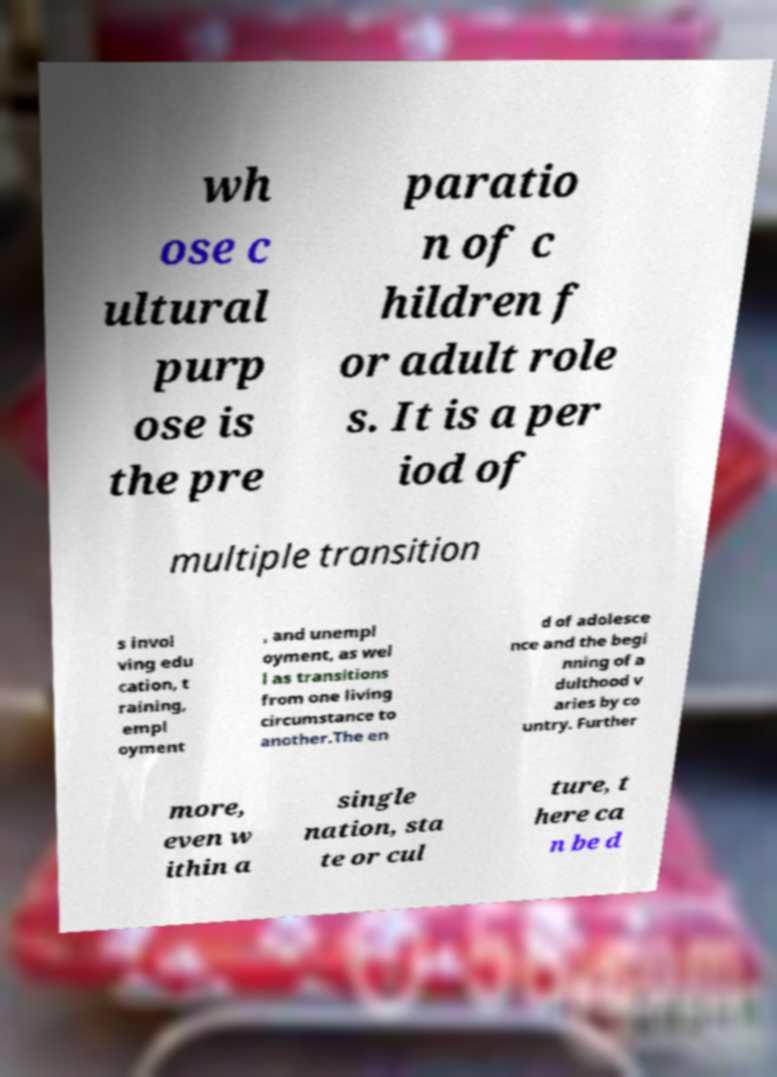Could you extract and type out the text from this image? wh ose c ultural purp ose is the pre paratio n of c hildren f or adult role s. It is a per iod of multiple transition s invol ving edu cation, t raining, empl oyment , and unempl oyment, as wel l as transitions from one living circumstance to another.The en d of adolesce nce and the begi nning of a dulthood v aries by co untry. Further more, even w ithin a single nation, sta te or cul ture, t here ca n be d 